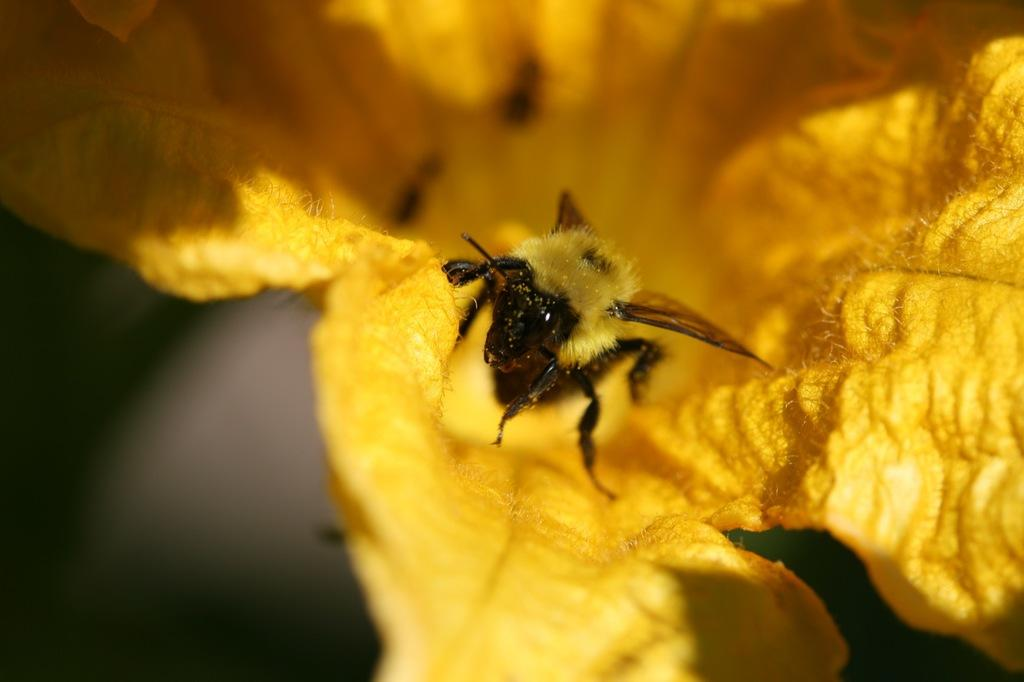What is present on the flower in the image? There is an insect on the flower in the image. Can you describe the insect's location on the flower? The insect is on the flower in the image. What type of coast can be seen in the image? There is no coast present in the image; it features an insect on a flower. What territory does the insect claim in the image? The image does not depict any territorial claims made by the insect. 